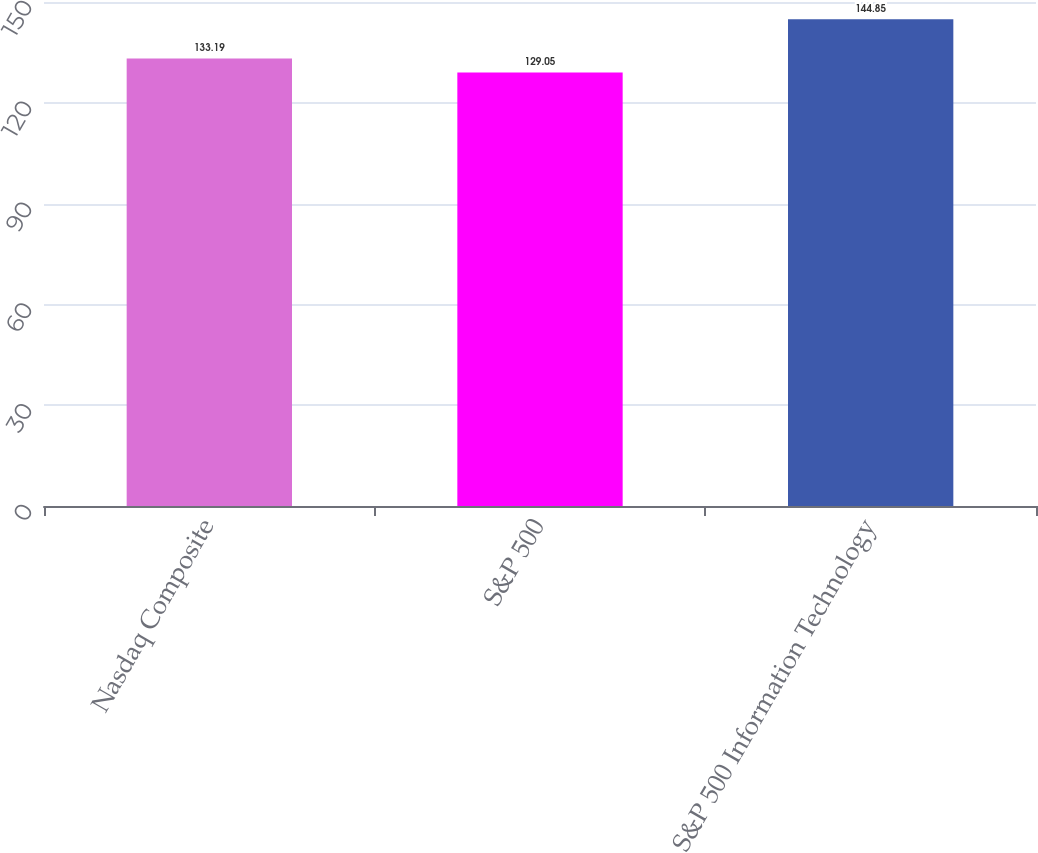Convert chart to OTSL. <chart><loc_0><loc_0><loc_500><loc_500><bar_chart><fcel>Nasdaq Composite<fcel>S&P 500<fcel>S&P 500 Information Technology<nl><fcel>133.19<fcel>129.05<fcel>144.85<nl></chart> 